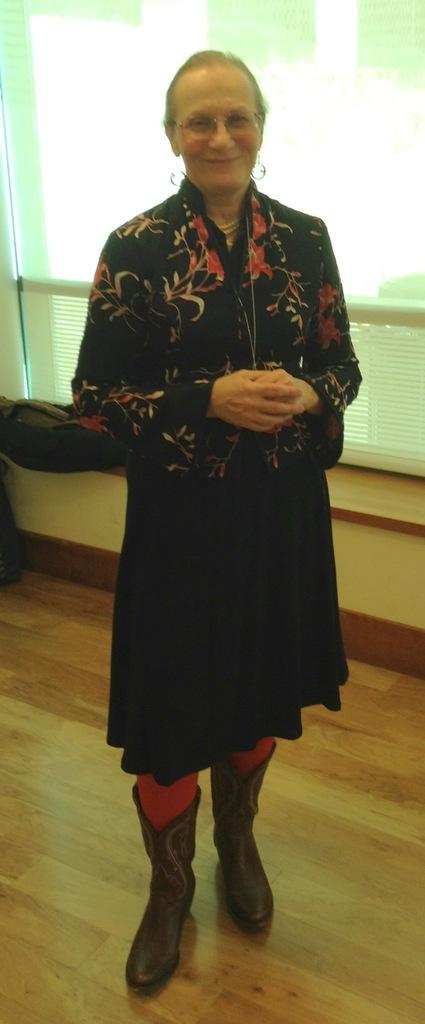Who is present in the image? There is a woman in the image. What is the woman doing in the image? The woman is standing on the floor and smiling. What type of footwear is the woman wearing? The woman is wearing boots on her legs. What type of street is visible in the background of the image? There is no street visible in the image; it only shows a woman standing on the floor. 